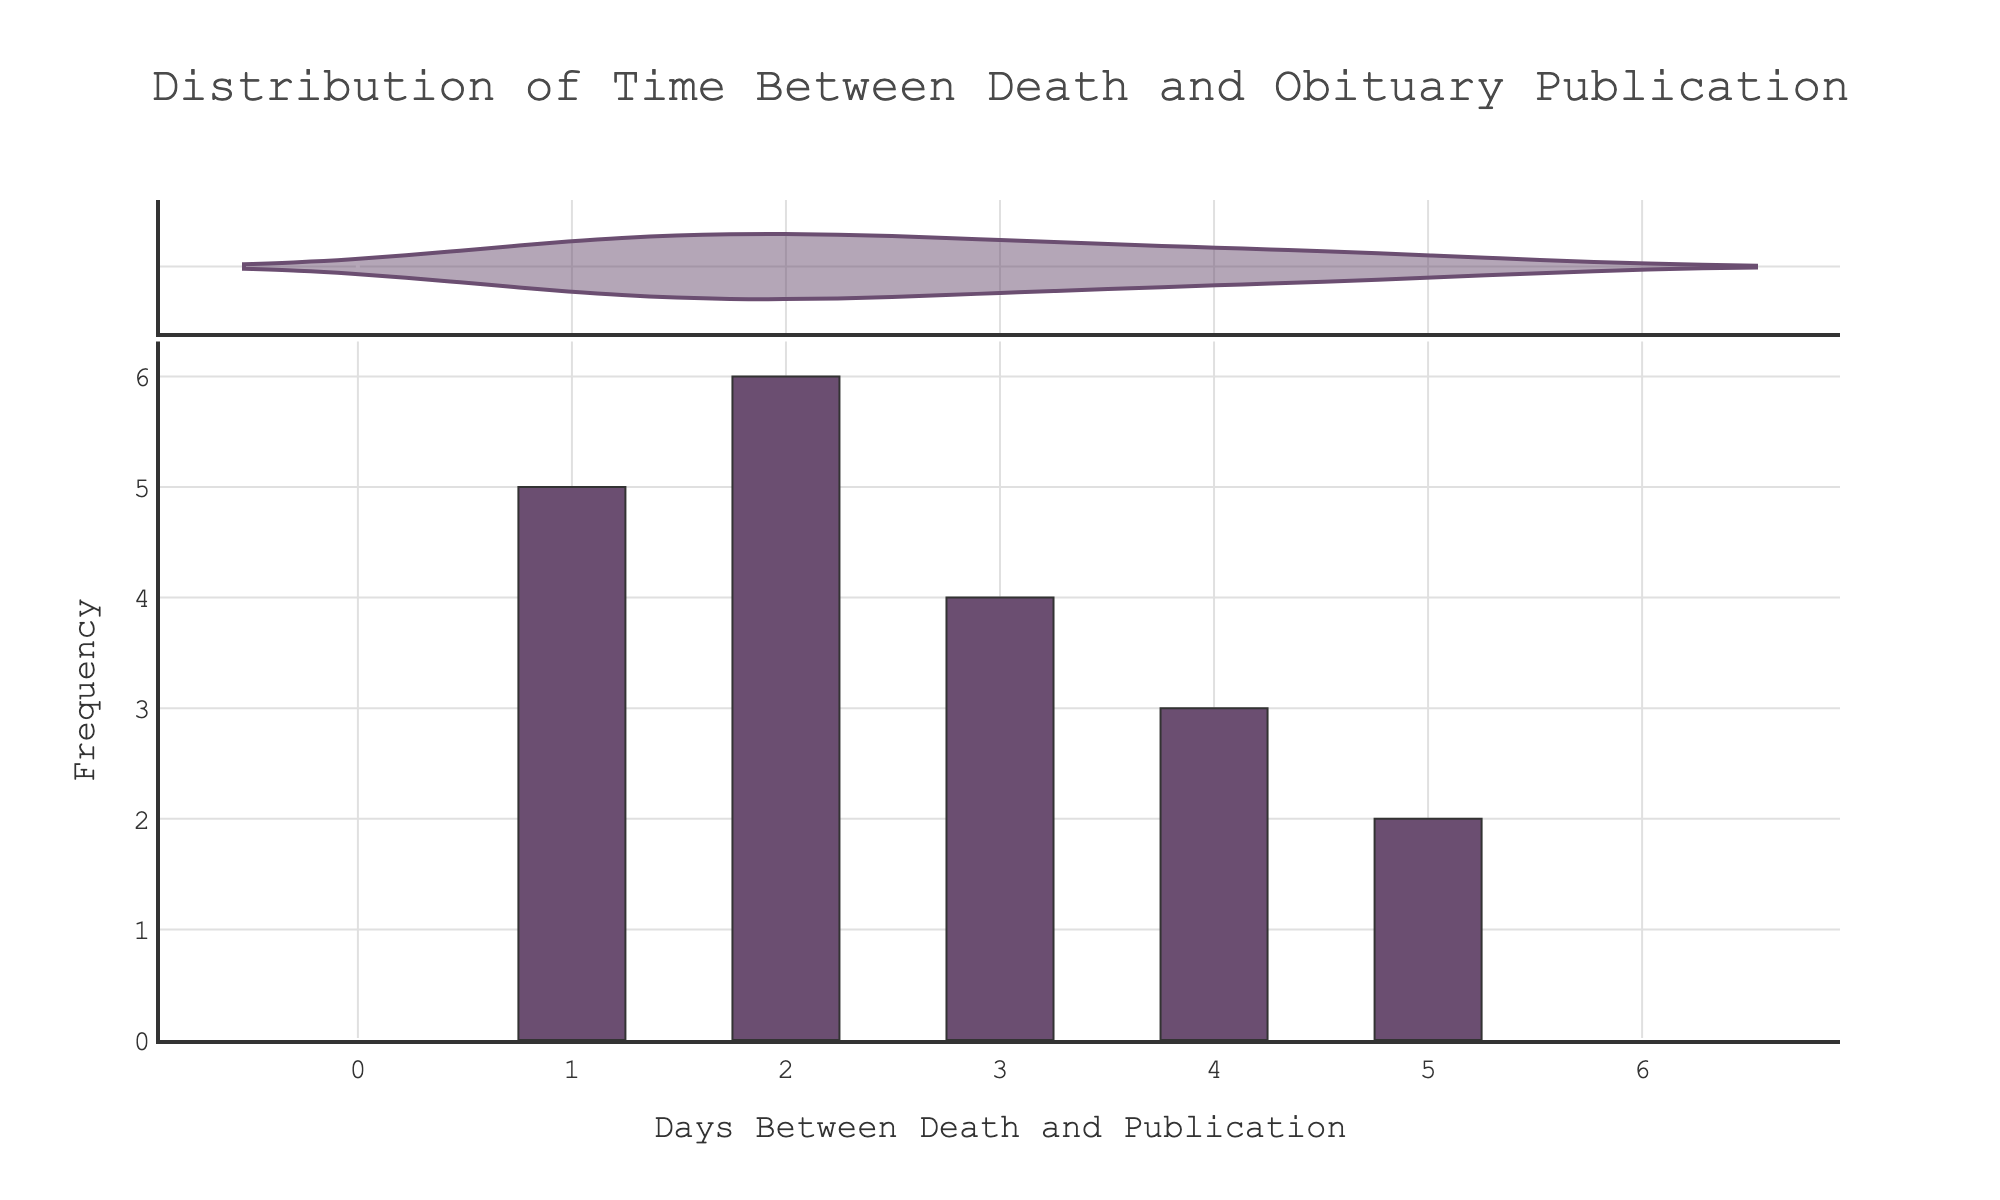What's the title of the plot? The title is usually displayed at the top of the plot and summarizes the content or purpose of the visualization. In this case, it reads "Distribution of Time Between Death and Obituary Publication."
Answer: Distribution of Time Between Death and Obituary Publication What is the most frequent number of days between death and obituary publication? To find the most frequent number of days, look at the tallest bar in the histogram. The x-axis value corresponding to this bar is the most common interval. The highest bars correspond to 1 and 2 days.
Answer: 1 and 2 days How many days show up in the histogram's x-axis? Examine the x-axis of the density plot, which is likely marked with ticks and labels indicating different days. The x-axis goes from 0 to at least 5.
Answer: At least 0 to 5 days What color is used for the bars in the histogram? The visual appearance of the bars can be described by their color, visible in the figure. The bars are filled with a shade, which in this case is purple.
Answer: Purple Which range of days has the lowest frequency of obituary publication? To determine this, look for the shortest bars in the histogram, indicating lower frequency. It's clear that the 4-day and 5-day intervals have shorter bars.
Answer: 4 and 5 days What is the overall range of days plotted on the x-axis? Inspect the x-axis to determine the intervals it covers. It appears to range from 0 to at least 5 days judging by the visible tick marks.
Answer: 0 to 5 days How does the frequency of days differ between 2 and 4? Compare the heights of the bars corresponding to 2 and 4 days. The bar for 2 days is visibly taller than the bar for 4 days, indicating higher frequency.
Answer: 2 days is more frequent than 4 days What is the average number of days between death and publication of the obituary, based on the plot? To find the average, note the frequencies of each interval and calculate a weighted average: assume the data values are [1x5 + 2x7 + 3x4 + 4x3 + 5x2], sum these and divide by the total count (21). \( (1*5 + 2*7 + 3*4 + 4*3 + 5*2) = (5 + 14 + 12 + 12 + 10) = 53 \), then \( 53 / 21 ≈ 2.52 \).
Answer: Approximately 2.52 days How does the distribution of days between death and obituary publication skew? Skewness refers to the asymmetry of the distribution. Here, the higher frequency at lower days suggests a left (negative) skew. Longer intervals are less frequent.
Answer: Left-skewed 